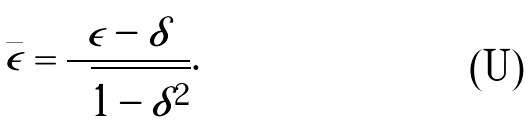<formula> <loc_0><loc_0><loc_500><loc_500>\bar { \epsilon } = \frac { \epsilon - \delta } { \sqrt { 1 - \delta ^ { 2 } } } .</formula> 